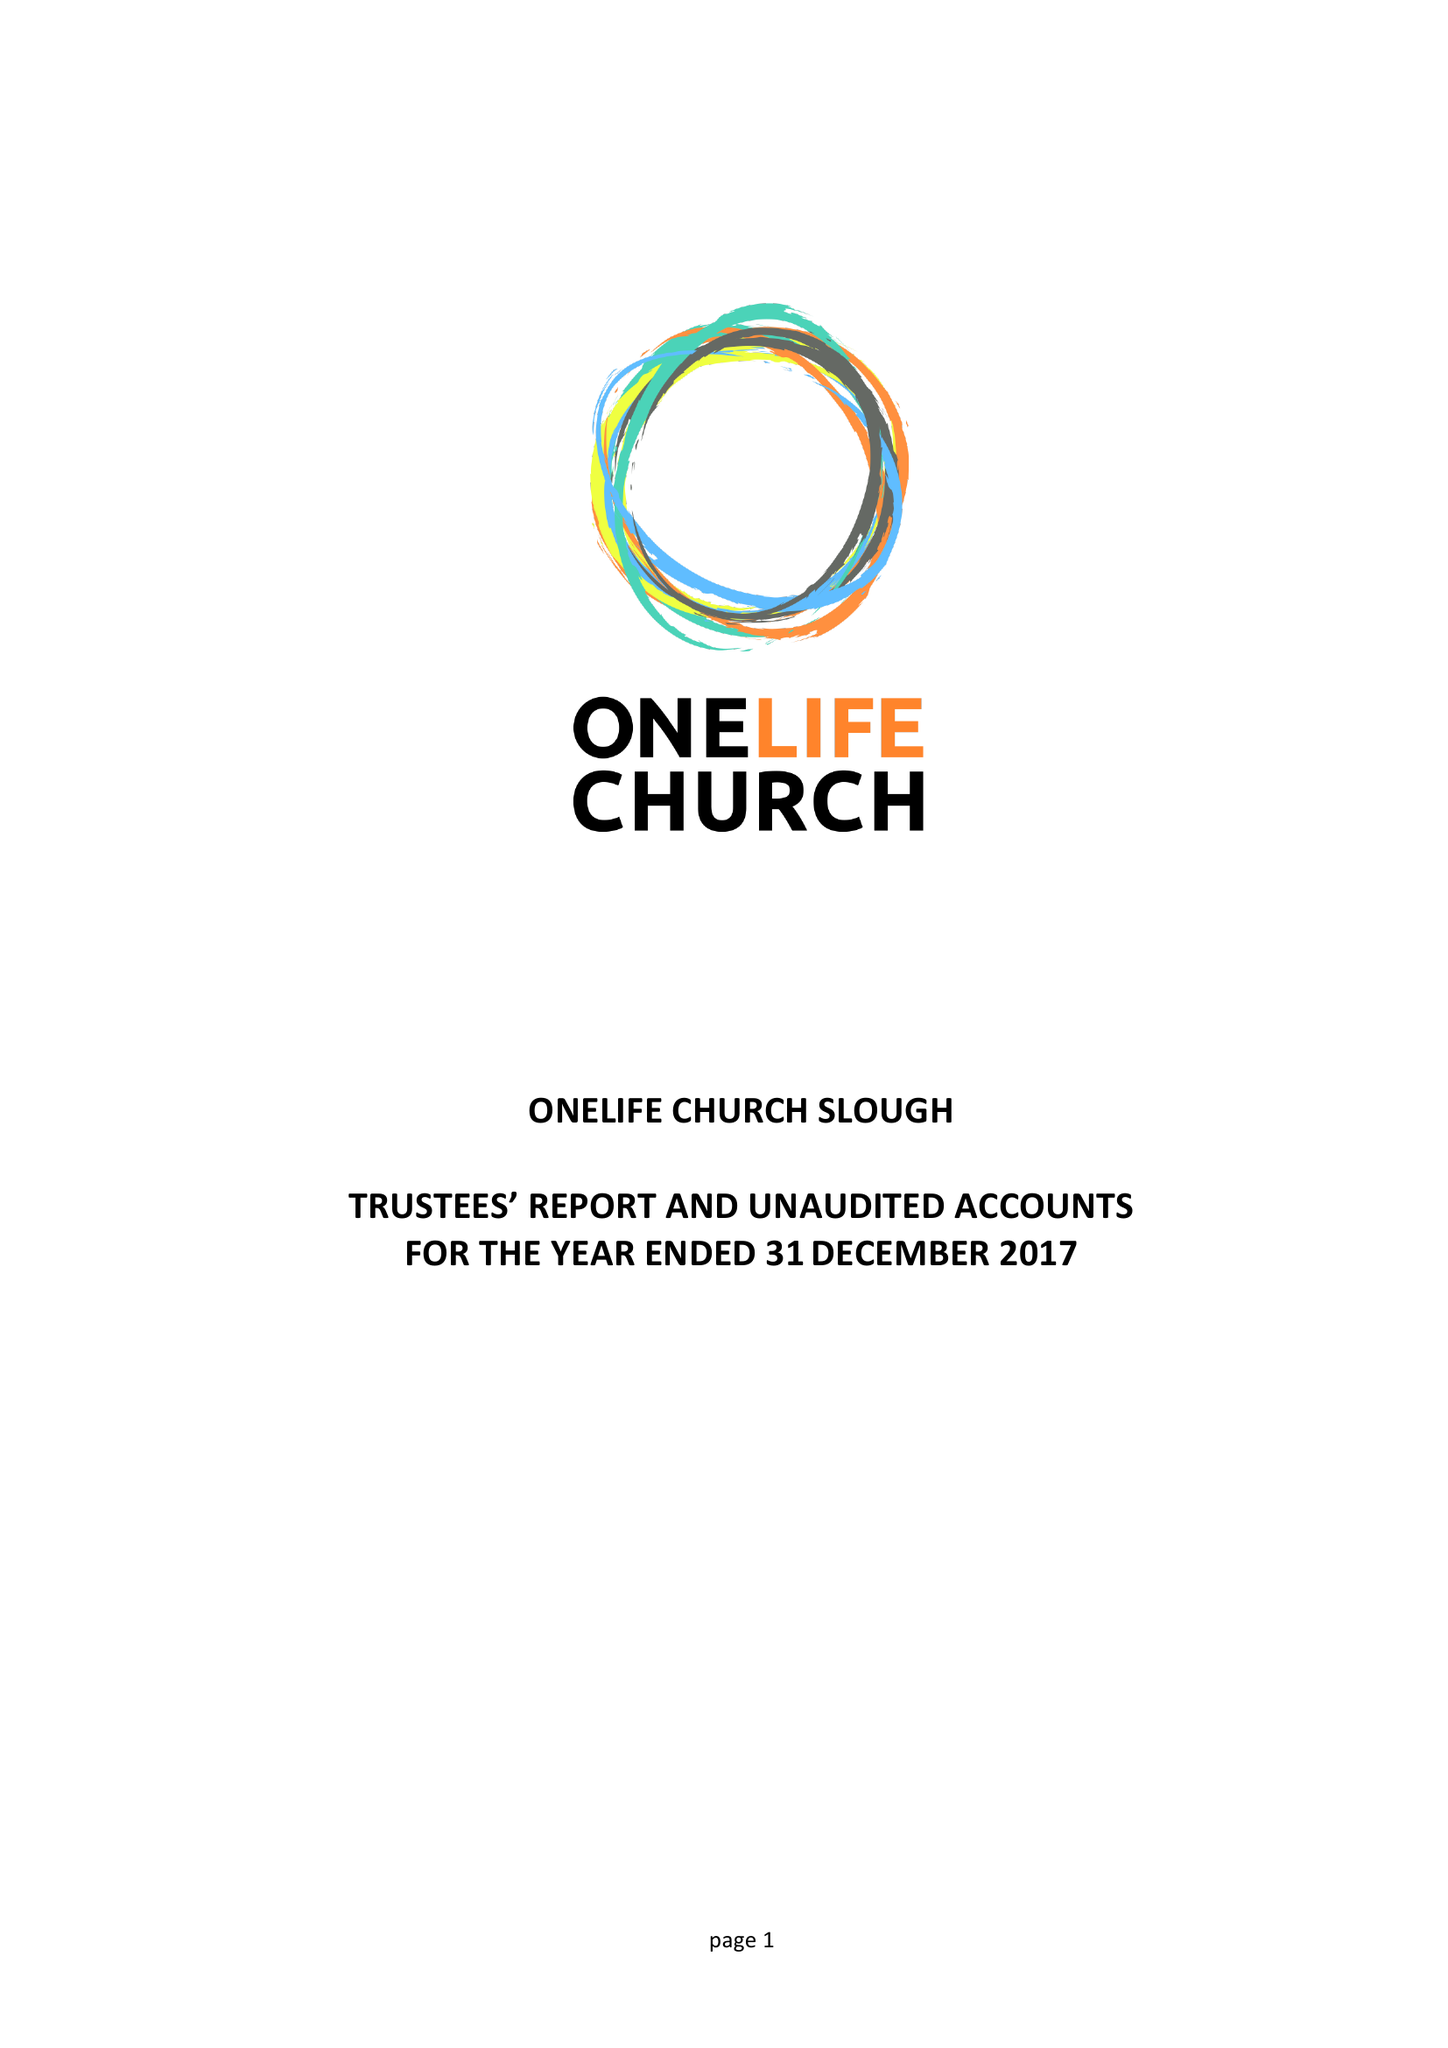What is the value for the charity_name?
Answer the question using a single word or phrase. Onelife Church Slough 